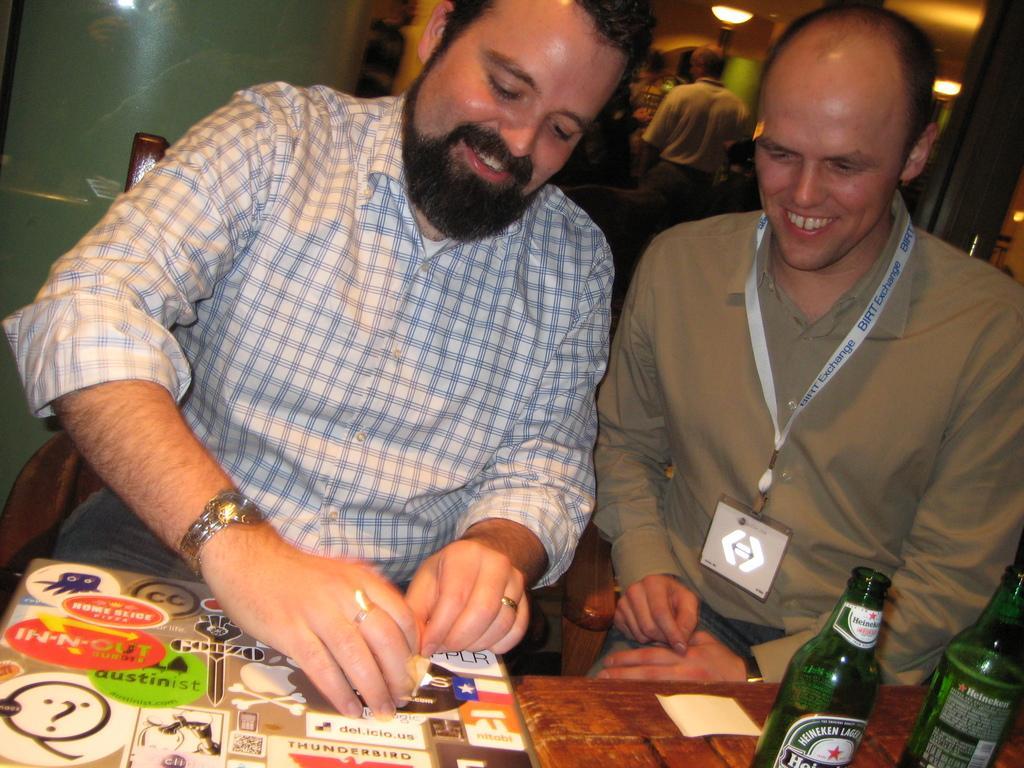Can you describe this image briefly? In this picture we can see two men sitting on chair and smiling and in front of them we can see board, paper, two bottles and in background we can see wall, some person standing, lights. 